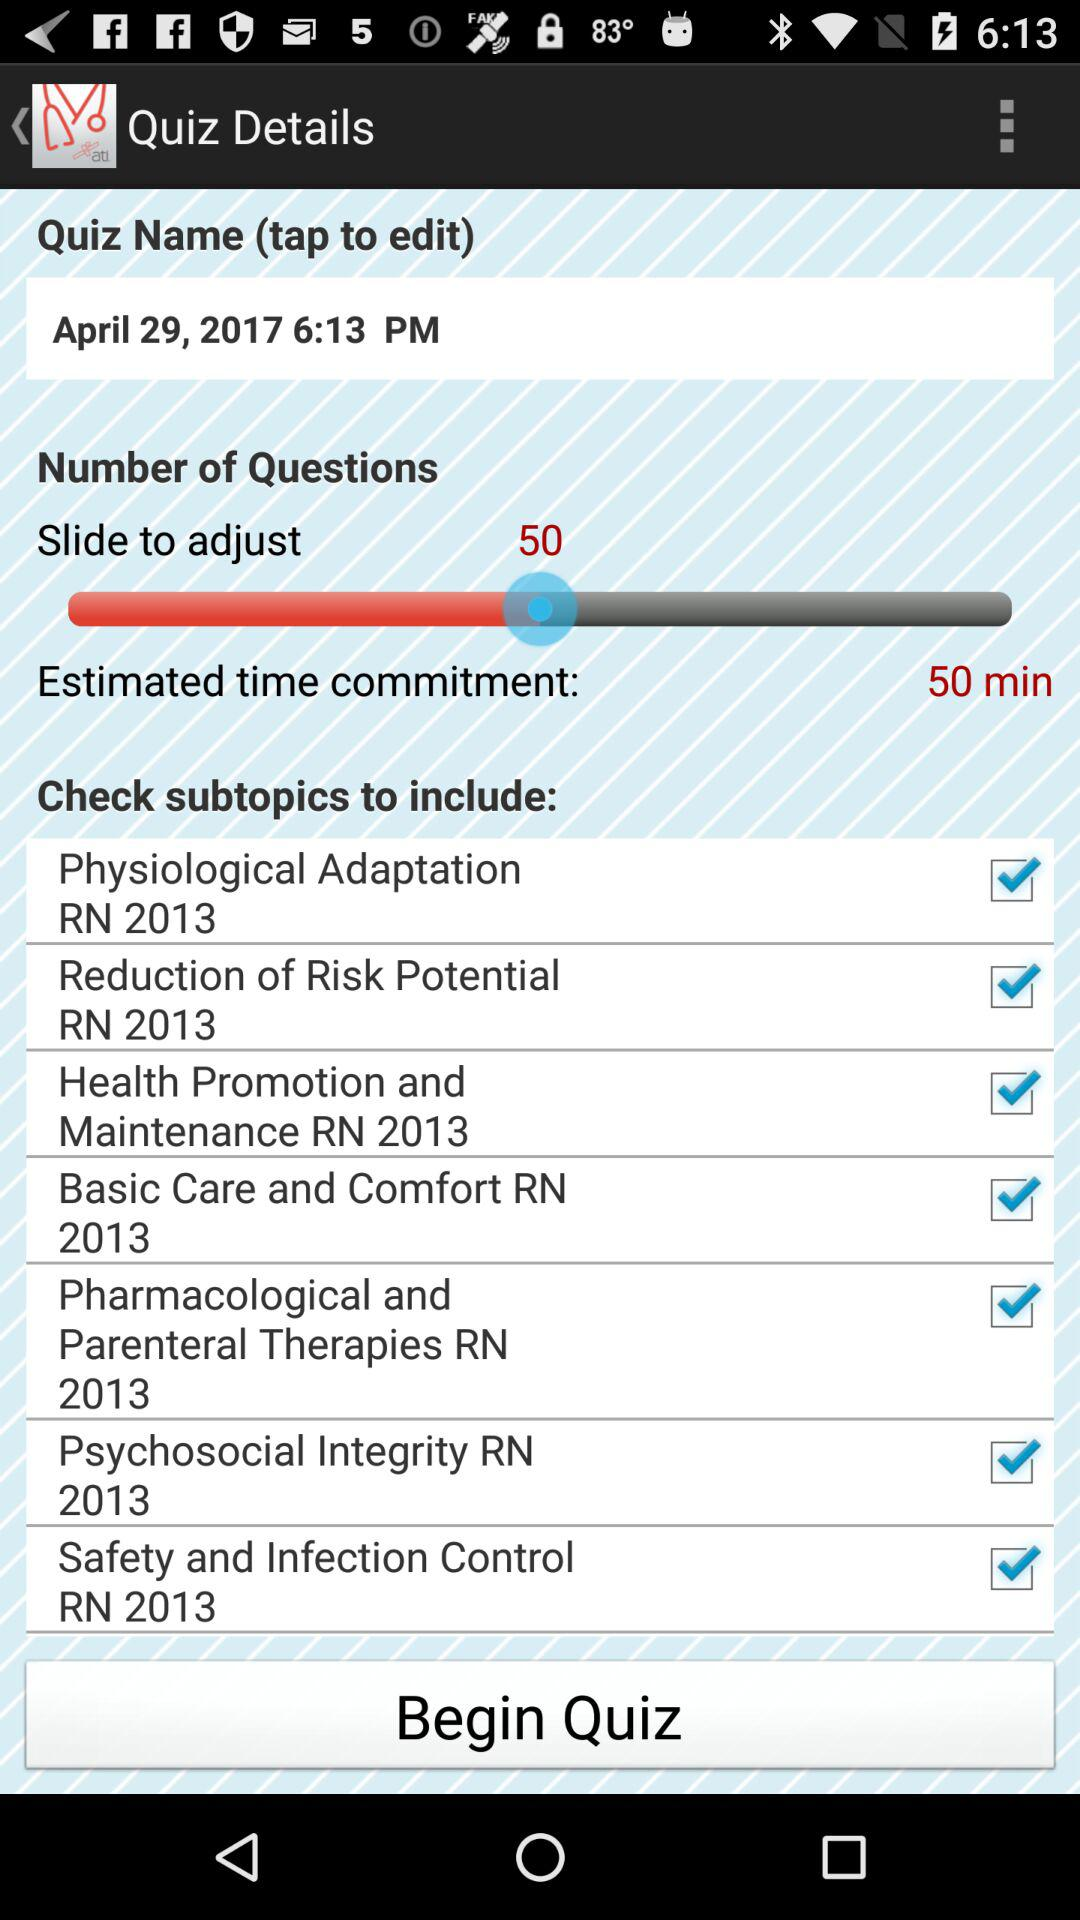What are the available subtopics? The available subtopics are "Physiological Adaptation RN 2013", "Reduction of Risk Potential RN 2013", "Health Promotion and Maintenance RN 2013", "Basic Care and Comfort RN 2013", "Pharmacological and Parenteral Therapies RN 2013", "Psychosocial Integrity RN 2013" and "Safety and Infection Control RN 2013". 